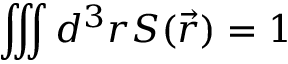Convert formula to latex. <formula><loc_0><loc_0><loc_500><loc_500>\iiint d ^ { 3 } r S ( \vec { r } ) = 1</formula> 